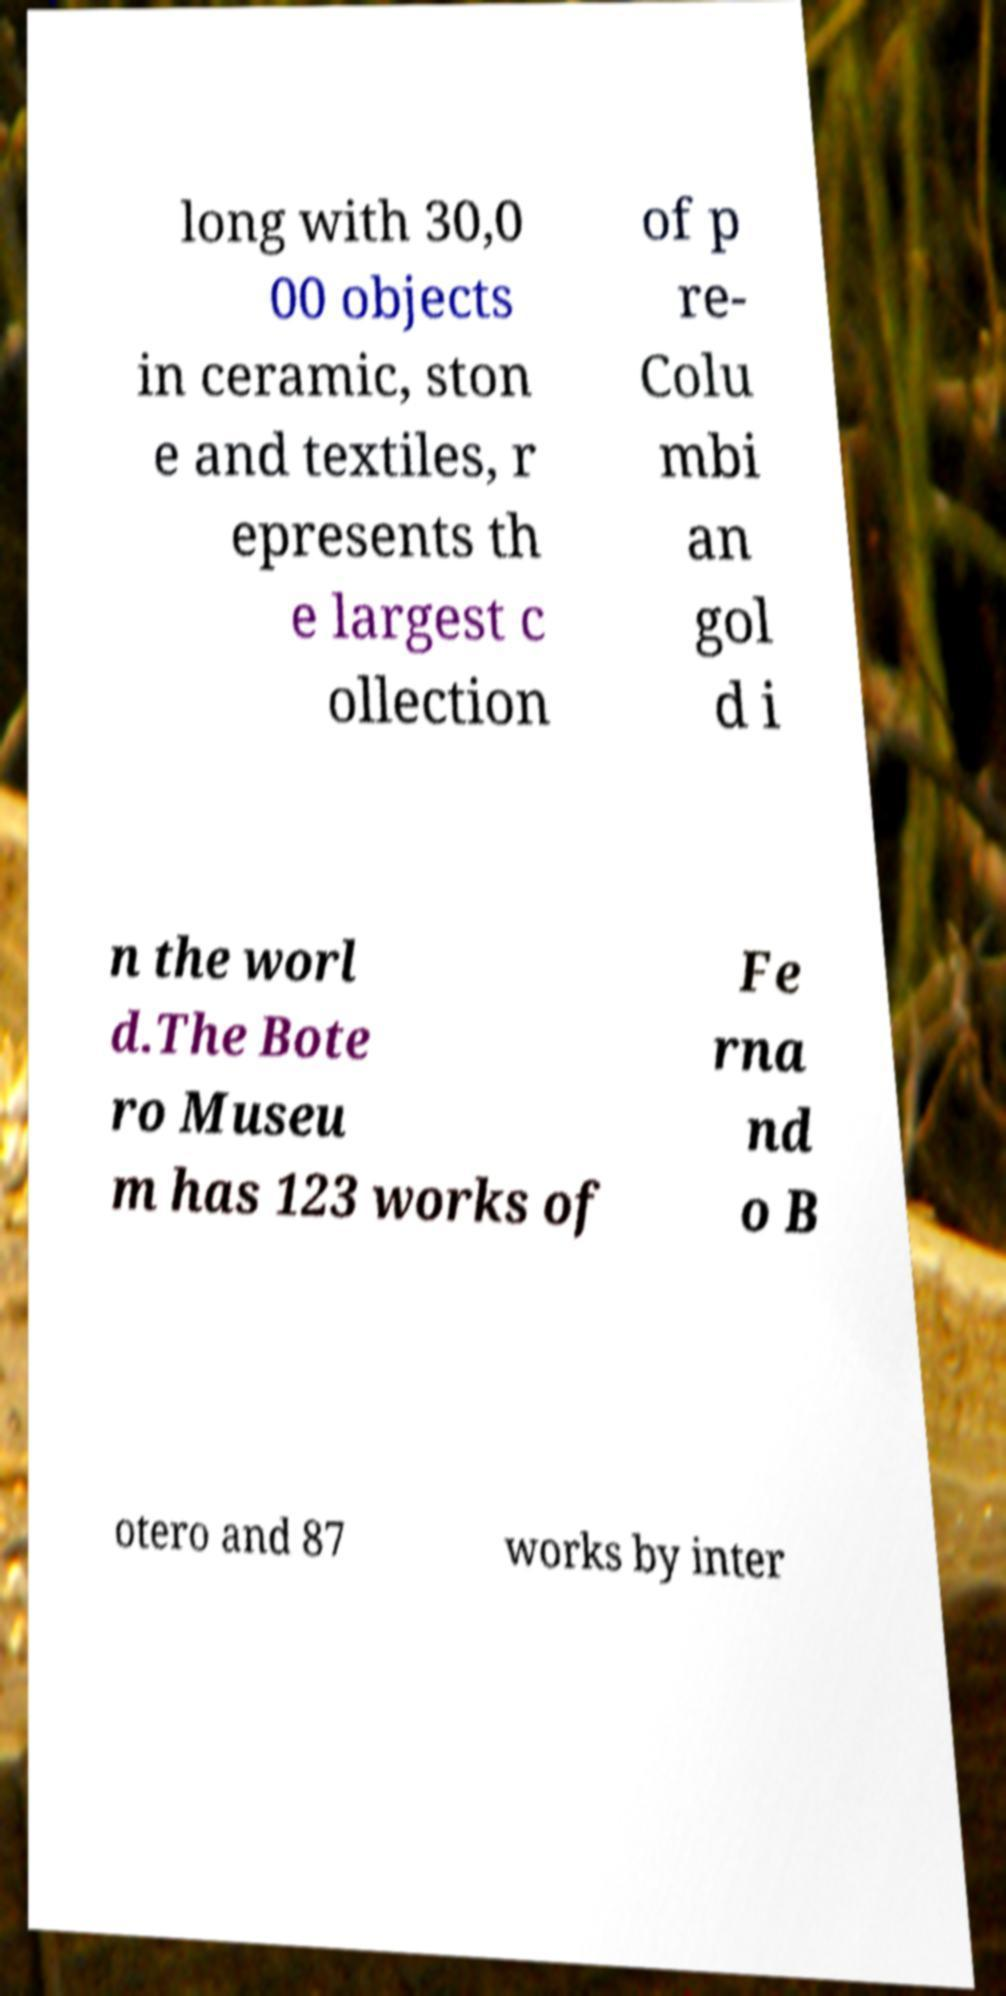Can you accurately transcribe the text from the provided image for me? long with 30,0 00 objects in ceramic, ston e and textiles, r epresents th e largest c ollection of p re- Colu mbi an gol d i n the worl d.The Bote ro Museu m has 123 works of Fe rna nd o B otero and 87 works by inter 